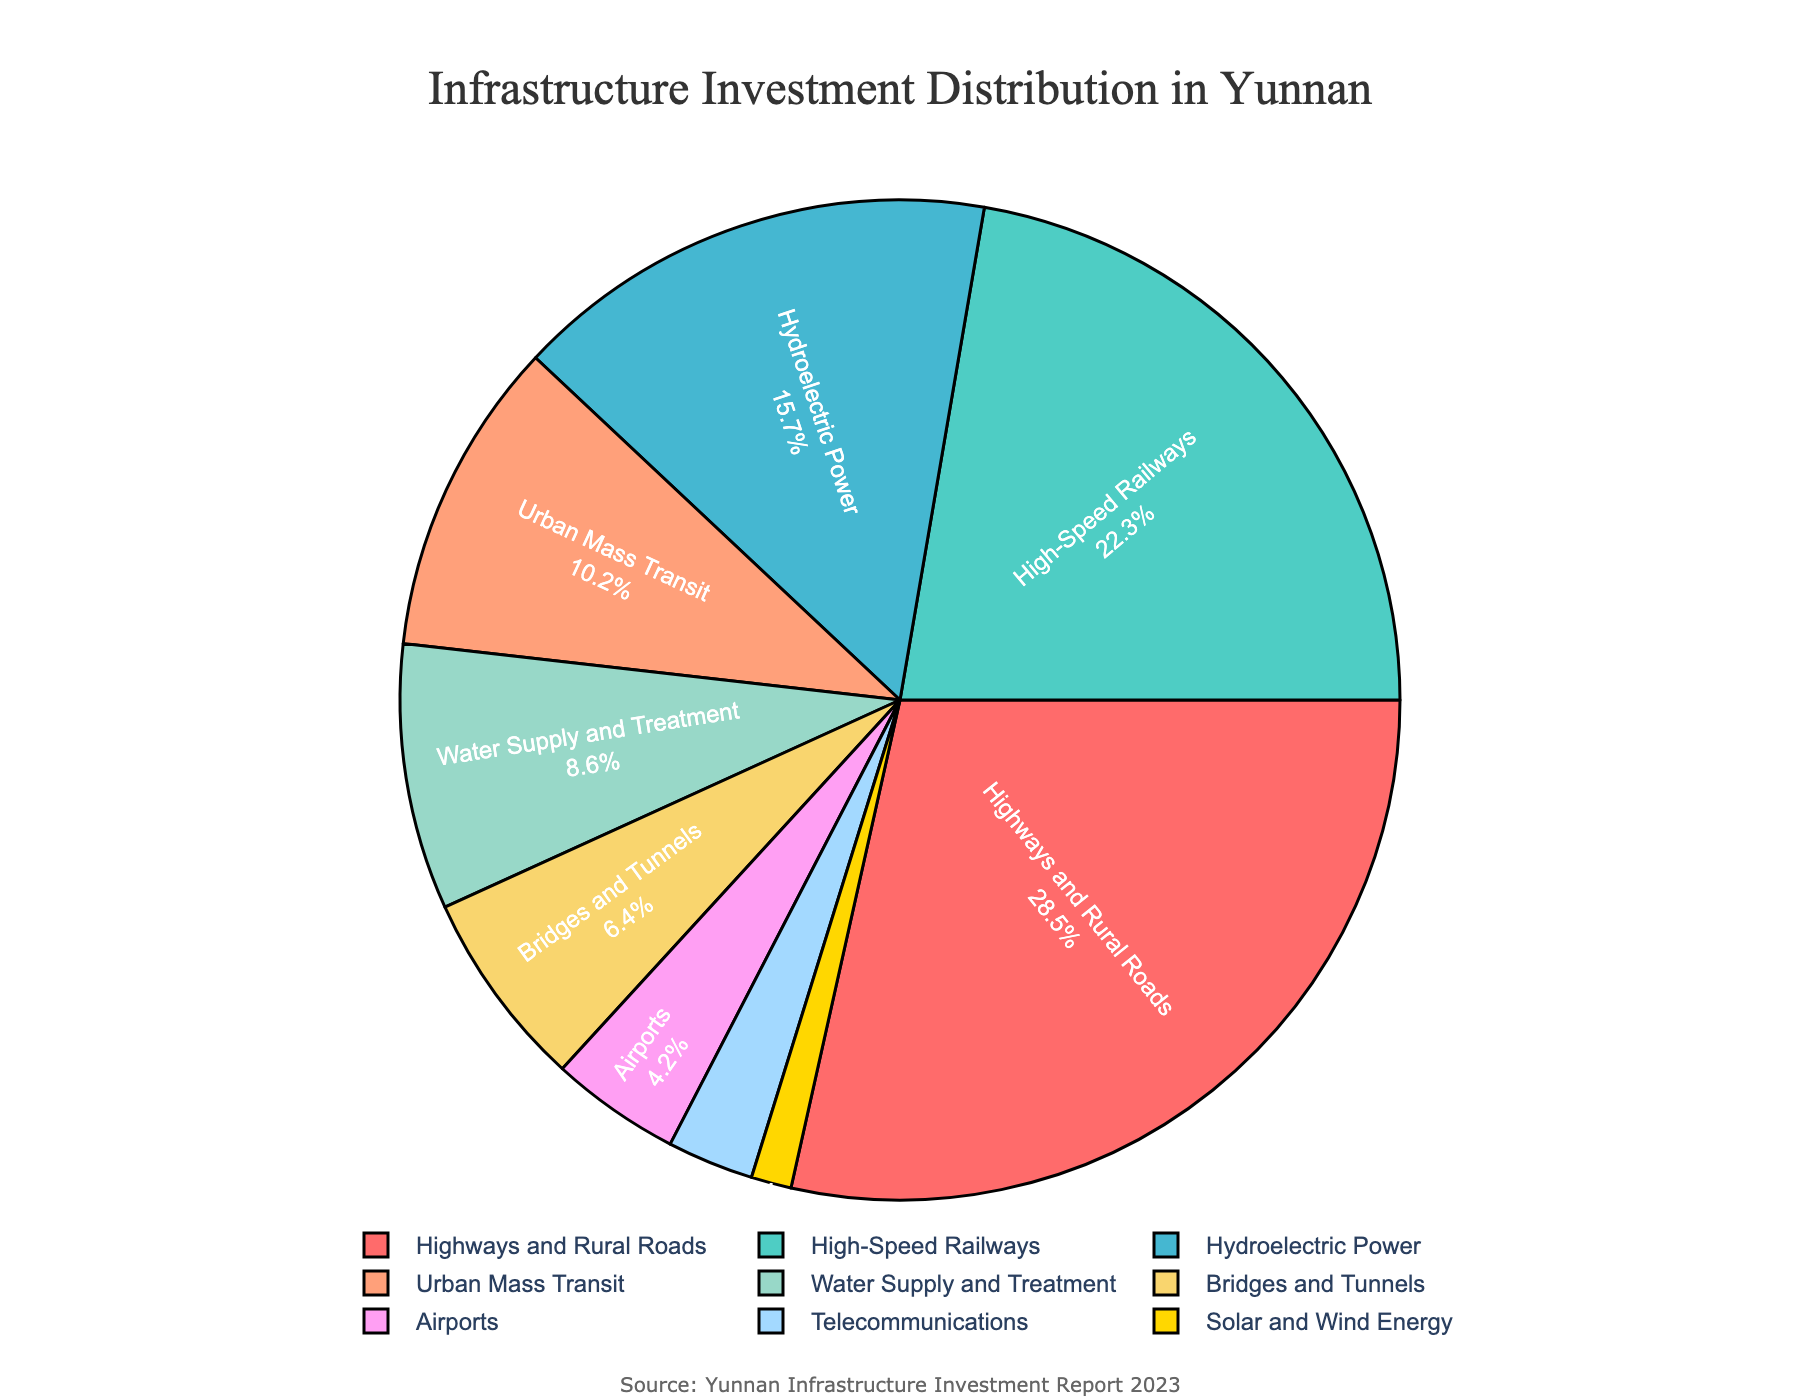What is the sector with the highest investment percentage? The sector with the largest slice in the pie chart represents the highest investment percentage. By looking at the chart, we see that "Highways and Rural Roads" has the largest segment.
Answer: Highways and Rural Roads Which sector has a lower investment percentage: Urban Mass Transit or Bridges and Tunnels? To answer this, compare the sizes of the segments labeled "Urban Mass Transit" and "Bridges and Tunnels". The chart shows that "Urban Mass Transit" has a larger percentage than "Bridges and Tunnels".
Answer: Bridges and Tunnels What is the combined investment percentage for Highways and Rural Roads and High-Speed Railways? Add the investment percentages of these two sectors: 28.5% for Highways and Rural Roads and 22.3% for High-Speed Railways. Thus, 28.5 + 22.3 = 50.8%
Answer: 50.8% How many sectors have an investment percentage of less than 10%? Count the sectors with segments representing less than 10% on the chart: Water Supply and Treatment (8.6%), Bridges and Tunnels (6.4%), Airports (4.2%), Telecommunications (2.8%), Solar and Wind Energy (1.3%). This totals to 5 sectors.
Answer: 5 Which sector has a percentage closest to 15%? By examining the pie chart, the sector "Hydroelectric Power" has an investment percentage of 15.7%, which is closest to 15%.
Answer: Hydroelectric Power How much higher is the investment percentage for Highways and Rural Roads compared to Urban Mass Transit? Subtract the investment percentage of Urban Mass Transit (10.2%) from Highways and Rural Roads (28.5%). Thus, 28.5 - 10.2 = 18.3
Answer: 18.3 What is the combined investment percentage for Airports, Telecommunications, and Solar and Wind Energy? Add the investment percentages of these sectors: 4.2% (Airports) + 2.8% (Telecommunications) + 1.3% (Solar and Wind Energy). Thus, 4.2 + 2.8 + 1.3 = 8.3%
Answer: 8.3% Is the investment in High-Speed Railways greater than in Hydroelectric Power and Urban Mass Transit combined? Add the investment percentages of Hydroelectric Power (15.7%) and Urban Mass Transit (10.2%), which equals 25.9%. Compare this with the investment percentage for High-Speed Railways (22.3%). Since 25.9% > 22.3%, the answer is no.
Answer: No 